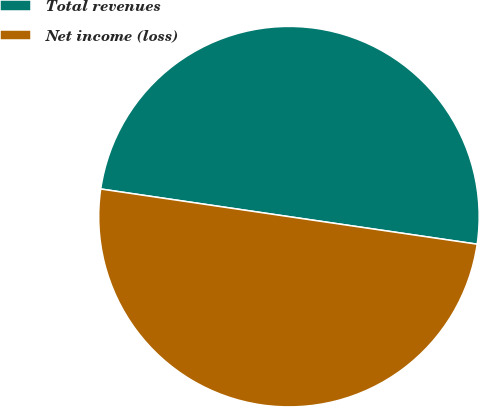<chart> <loc_0><loc_0><loc_500><loc_500><pie_chart><fcel>Total revenues<fcel>Net income (loss)<nl><fcel>49.99%<fcel>50.01%<nl></chart> 